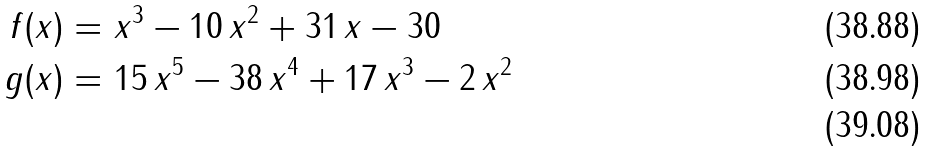<formula> <loc_0><loc_0><loc_500><loc_500>f ( x ) = & \ { x } ^ { 3 } - 1 0 \, { x } ^ { 2 } + 3 1 \, x - 3 0 \\ g ( x ) = & \ 1 5 \, { x } ^ { 5 } - 3 8 \, { x } ^ { 4 } + 1 7 \, { x } ^ { 3 } - 2 \, { x } ^ { 2 } \\</formula> 